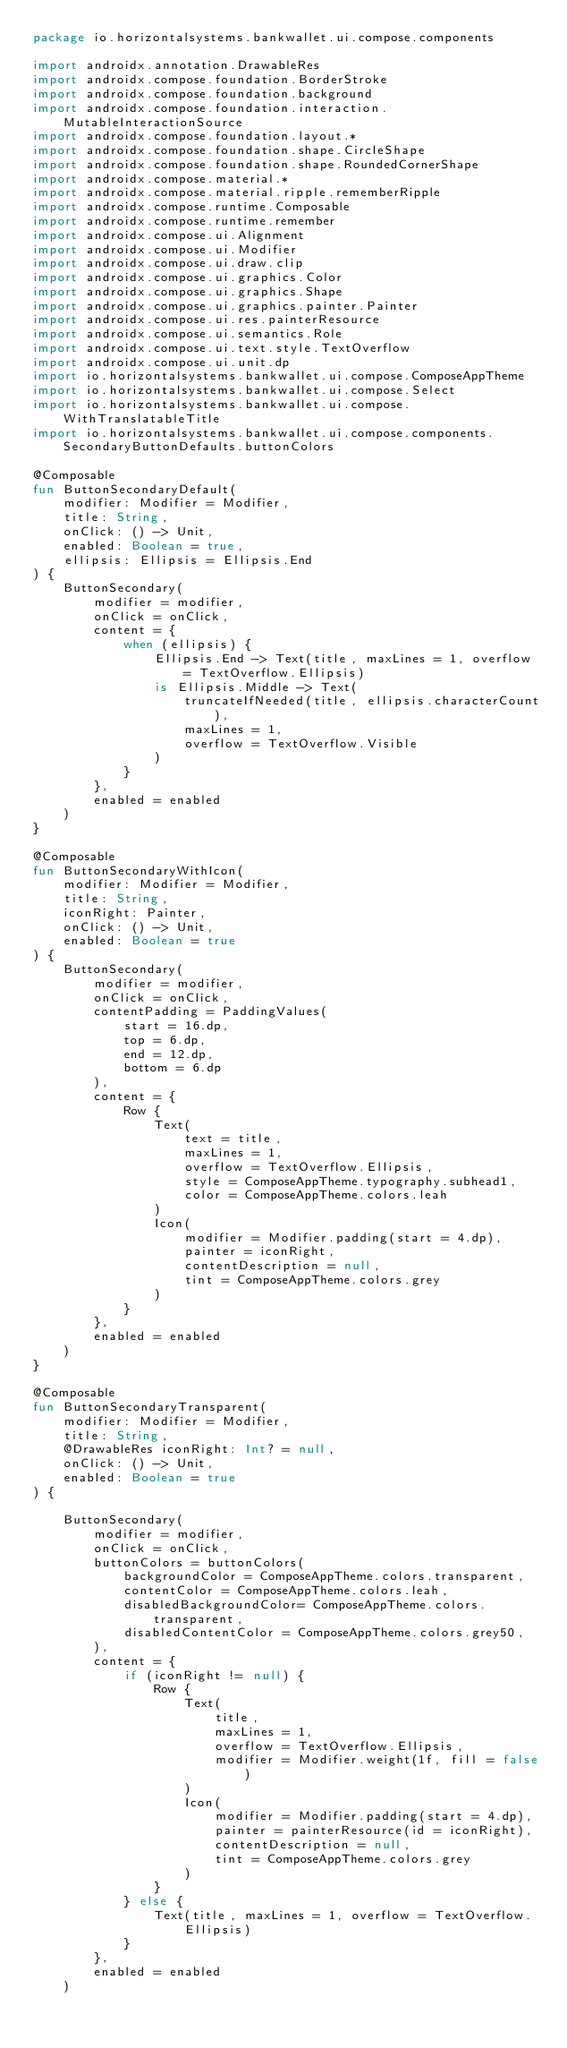<code> <loc_0><loc_0><loc_500><loc_500><_Kotlin_>package io.horizontalsystems.bankwallet.ui.compose.components

import androidx.annotation.DrawableRes
import androidx.compose.foundation.BorderStroke
import androidx.compose.foundation.background
import androidx.compose.foundation.interaction.MutableInteractionSource
import androidx.compose.foundation.layout.*
import androidx.compose.foundation.shape.CircleShape
import androidx.compose.foundation.shape.RoundedCornerShape
import androidx.compose.material.*
import androidx.compose.material.ripple.rememberRipple
import androidx.compose.runtime.Composable
import androidx.compose.runtime.remember
import androidx.compose.ui.Alignment
import androidx.compose.ui.Modifier
import androidx.compose.ui.draw.clip
import androidx.compose.ui.graphics.Color
import androidx.compose.ui.graphics.Shape
import androidx.compose.ui.graphics.painter.Painter
import androidx.compose.ui.res.painterResource
import androidx.compose.ui.semantics.Role
import androidx.compose.ui.text.style.TextOverflow
import androidx.compose.ui.unit.dp
import io.horizontalsystems.bankwallet.ui.compose.ComposeAppTheme
import io.horizontalsystems.bankwallet.ui.compose.Select
import io.horizontalsystems.bankwallet.ui.compose.WithTranslatableTitle
import io.horizontalsystems.bankwallet.ui.compose.components.SecondaryButtonDefaults.buttonColors

@Composable
fun ButtonSecondaryDefault(
    modifier: Modifier = Modifier,
    title: String,
    onClick: () -> Unit,
    enabled: Boolean = true,
    ellipsis: Ellipsis = Ellipsis.End
) {
    ButtonSecondary(
        modifier = modifier,
        onClick = onClick,
        content = {
            when (ellipsis) {
                Ellipsis.End -> Text(title, maxLines = 1, overflow = TextOverflow.Ellipsis)
                is Ellipsis.Middle -> Text(
                    truncateIfNeeded(title, ellipsis.characterCount),
                    maxLines = 1,
                    overflow = TextOverflow.Visible
                )
            }
        },
        enabled = enabled
    )
}

@Composable
fun ButtonSecondaryWithIcon(
    modifier: Modifier = Modifier,
    title: String,
    iconRight: Painter,
    onClick: () -> Unit,
    enabled: Boolean = true
) {
    ButtonSecondary(
        modifier = modifier,
        onClick = onClick,
        contentPadding = PaddingValues(
            start = 16.dp,
            top = 6.dp,
            end = 12.dp,
            bottom = 6.dp
        ),
        content = {
            Row {
                Text(
                    text = title,
                    maxLines = 1,
                    overflow = TextOverflow.Ellipsis,
                    style = ComposeAppTheme.typography.subhead1,
                    color = ComposeAppTheme.colors.leah
                )
                Icon(
                    modifier = Modifier.padding(start = 4.dp),
                    painter = iconRight,
                    contentDescription = null,
                    tint = ComposeAppTheme.colors.grey
                )
            }
        },
        enabled = enabled
    )
}

@Composable
fun ButtonSecondaryTransparent(
    modifier: Modifier = Modifier,
    title: String,
    @DrawableRes iconRight: Int? = null,
    onClick: () -> Unit,
    enabled: Boolean = true
) {

    ButtonSecondary(
        modifier = modifier,
        onClick = onClick,
        buttonColors = buttonColors(
            backgroundColor = ComposeAppTheme.colors.transparent,
            contentColor = ComposeAppTheme.colors.leah,
            disabledBackgroundColor= ComposeAppTheme.colors.transparent,
            disabledContentColor = ComposeAppTheme.colors.grey50,
        ),
        content = {
            if (iconRight != null) {
                Row {
                    Text(
                        title,
                        maxLines = 1,
                        overflow = TextOverflow.Ellipsis,
                        modifier = Modifier.weight(1f, fill = false)
                    )
                    Icon(
                        modifier = Modifier.padding(start = 4.dp),
                        painter = painterResource(id = iconRight),
                        contentDescription = null,
                        tint = ComposeAppTheme.colors.grey
                    )
                }
            } else {
                Text(title, maxLines = 1, overflow = TextOverflow.Ellipsis)
            }
        },
        enabled = enabled
    )</code> 